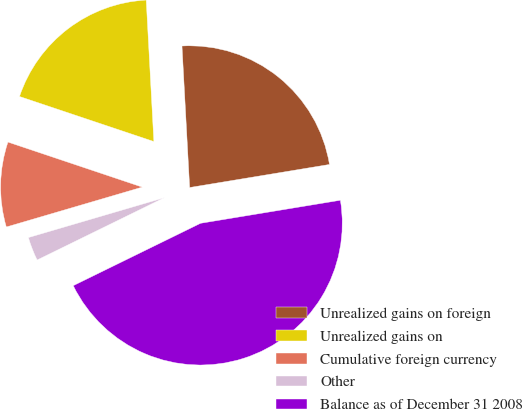<chart> <loc_0><loc_0><loc_500><loc_500><pie_chart><fcel>Unrealized gains on foreign<fcel>Unrealized gains on<fcel>Cumulative foreign currency<fcel>Other<fcel>Balance as of December 31 2008<nl><fcel>23.26%<fcel>18.99%<fcel>9.69%<fcel>2.71%<fcel>45.35%<nl></chart> 